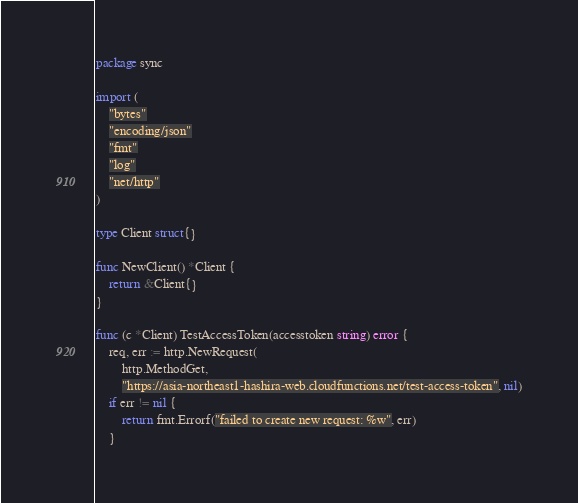Convert code to text. <code><loc_0><loc_0><loc_500><loc_500><_Go_>package sync

import (
	"bytes"
	"encoding/json"
	"fmt"
	"log"
	"net/http"
)

type Client struct{}

func NewClient() *Client {
	return &Client{}
}

func (c *Client) TestAccessToken(accesstoken string) error {
	req, err := http.NewRequest(
		http.MethodGet,
		"https://asia-northeast1-hashira-web.cloudfunctions.net/test-access-token", nil)
	if err != nil {
		return fmt.Errorf("failed to create new request: %w", err)
	}
</code> 